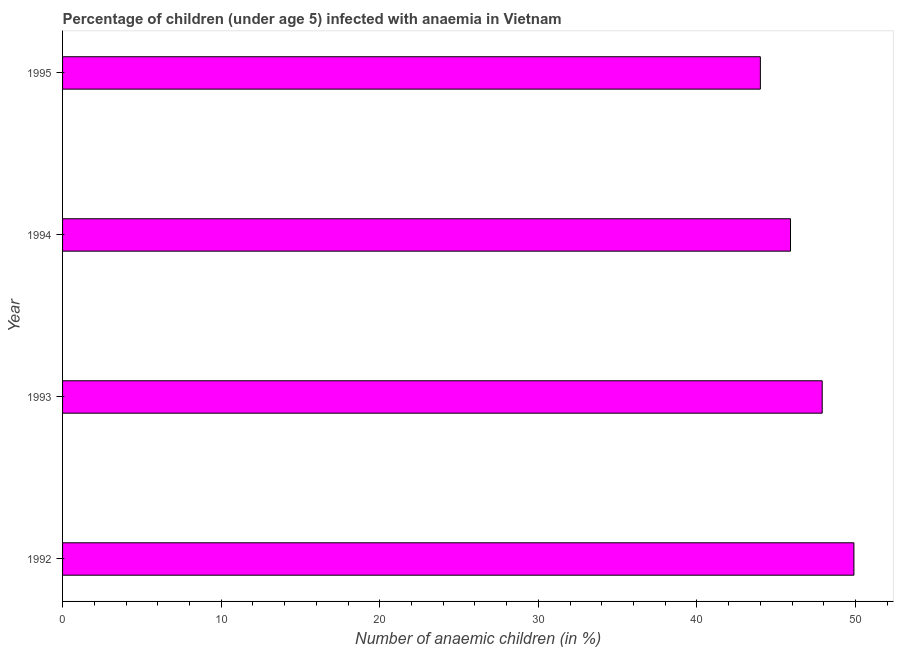Does the graph contain any zero values?
Keep it short and to the point. No. What is the title of the graph?
Give a very brief answer. Percentage of children (under age 5) infected with anaemia in Vietnam. What is the label or title of the X-axis?
Make the answer very short. Number of anaemic children (in %). Across all years, what is the maximum number of anaemic children?
Your response must be concise. 49.9. Across all years, what is the minimum number of anaemic children?
Give a very brief answer. 44. In which year was the number of anaemic children maximum?
Offer a terse response. 1992. What is the sum of the number of anaemic children?
Provide a short and direct response. 187.7. What is the difference between the number of anaemic children in 1994 and 1995?
Your answer should be very brief. 1.9. What is the average number of anaemic children per year?
Offer a very short reply. 46.92. What is the median number of anaemic children?
Offer a very short reply. 46.9. In how many years, is the number of anaemic children greater than 8 %?
Keep it short and to the point. 4. Do a majority of the years between 1993 and 1995 (inclusive) have number of anaemic children greater than 44 %?
Your answer should be compact. Yes. What is the ratio of the number of anaemic children in 1994 to that in 1995?
Keep it short and to the point. 1.04. Is the number of anaemic children in 1993 less than that in 1995?
Provide a succinct answer. No. How many bars are there?
Ensure brevity in your answer.  4. Are all the bars in the graph horizontal?
Ensure brevity in your answer.  Yes. Are the values on the major ticks of X-axis written in scientific E-notation?
Provide a short and direct response. No. What is the Number of anaemic children (in %) of 1992?
Provide a succinct answer. 49.9. What is the Number of anaemic children (in %) in 1993?
Provide a short and direct response. 47.9. What is the Number of anaemic children (in %) in 1994?
Your answer should be compact. 45.9. What is the Number of anaemic children (in %) in 1995?
Your response must be concise. 44. What is the difference between the Number of anaemic children (in %) in 1993 and 1995?
Ensure brevity in your answer.  3.9. What is the ratio of the Number of anaemic children (in %) in 1992 to that in 1993?
Give a very brief answer. 1.04. What is the ratio of the Number of anaemic children (in %) in 1992 to that in 1994?
Your answer should be very brief. 1.09. What is the ratio of the Number of anaemic children (in %) in 1992 to that in 1995?
Keep it short and to the point. 1.13. What is the ratio of the Number of anaemic children (in %) in 1993 to that in 1994?
Provide a short and direct response. 1.04. What is the ratio of the Number of anaemic children (in %) in 1993 to that in 1995?
Your answer should be very brief. 1.09. What is the ratio of the Number of anaemic children (in %) in 1994 to that in 1995?
Give a very brief answer. 1.04. 